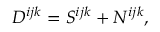Convert formula to latex. <formula><loc_0><loc_0><loc_500><loc_500>D ^ { i j k } = S ^ { i j k } + N ^ { i j k } ,</formula> 